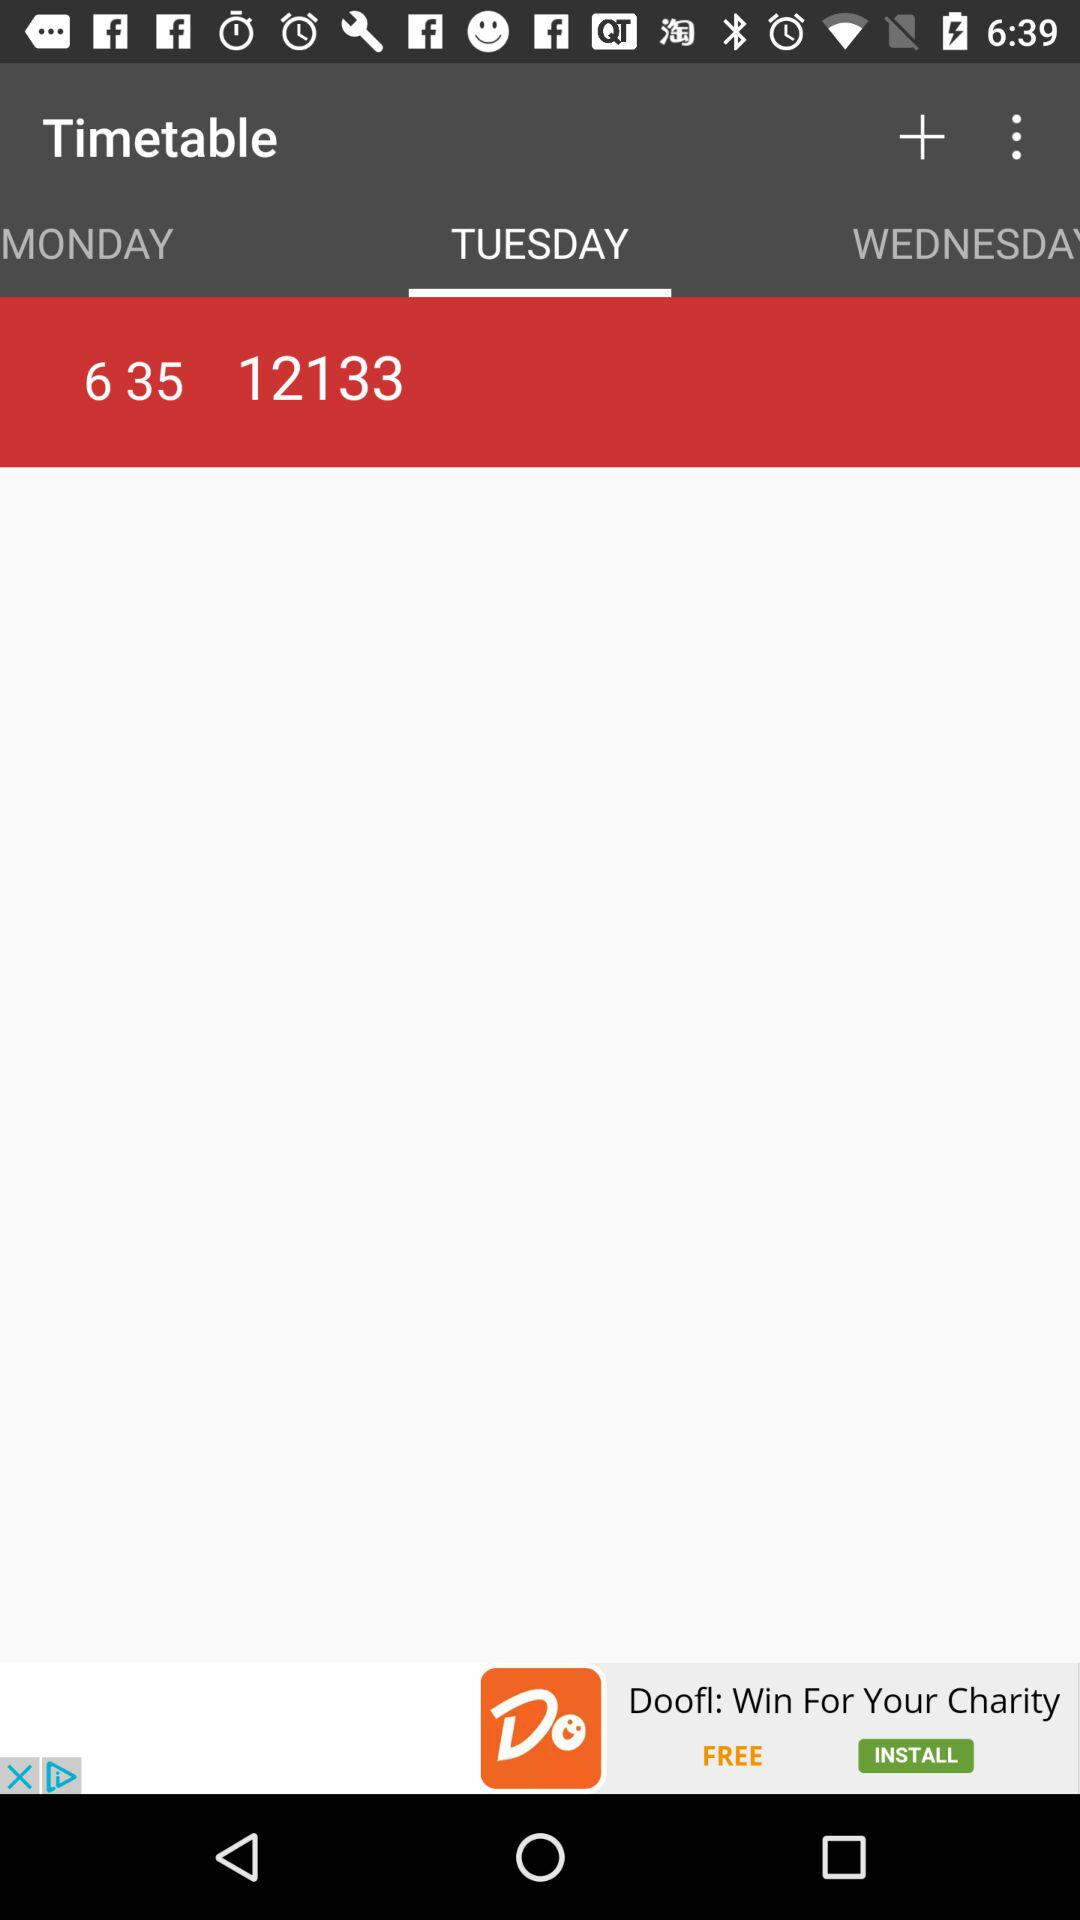What is the timetable on Wednesday?
When the provided information is insufficient, respond with <no answer>. <no answer> 